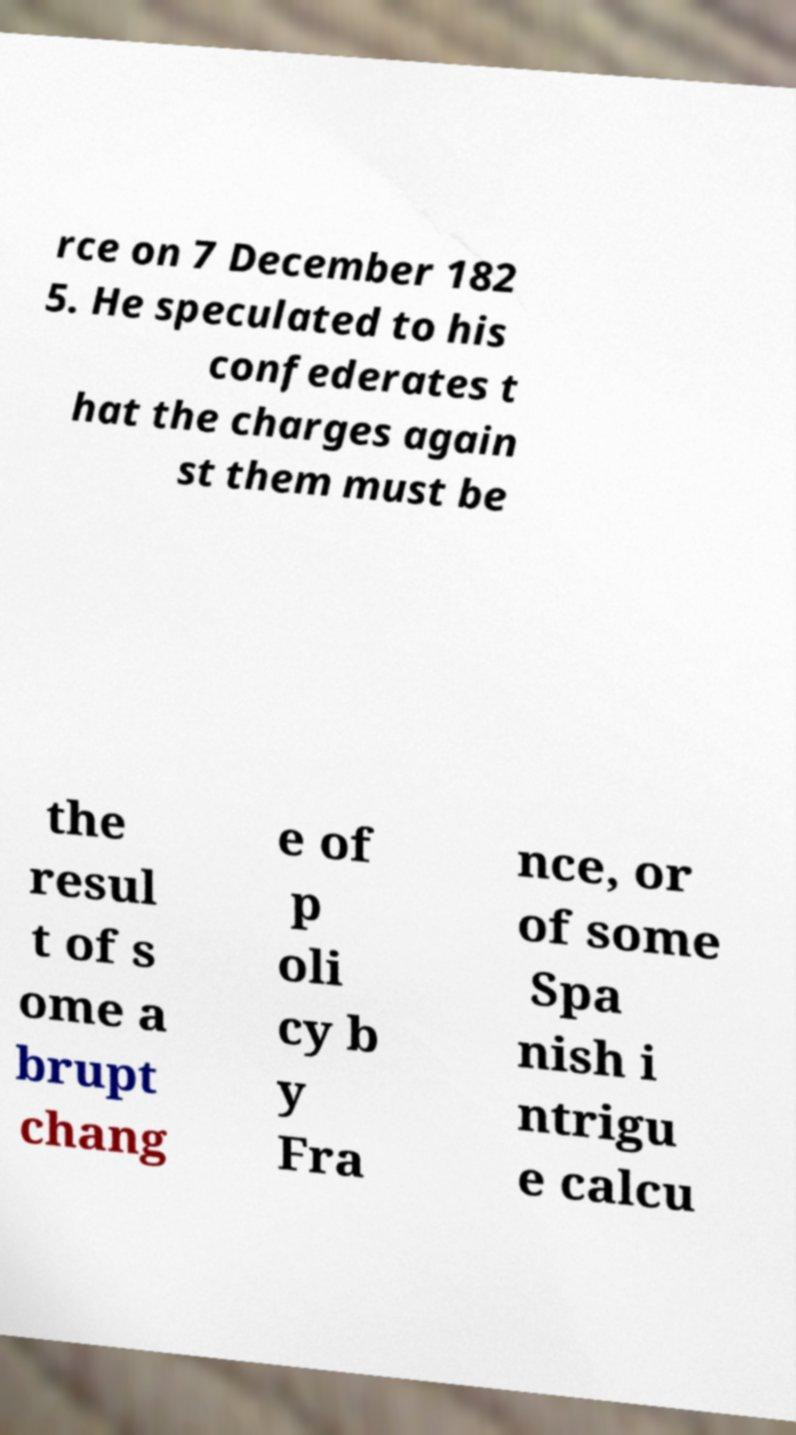Can you read and provide the text displayed in the image?This photo seems to have some interesting text. Can you extract and type it out for me? rce on 7 December 182 5. He speculated to his confederates t hat the charges again st them must be the resul t of s ome a brupt chang e of p oli cy b y Fra nce, or of some Spa nish i ntrigu e calcu 